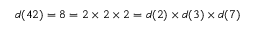Convert formula to latex. <formula><loc_0><loc_0><loc_500><loc_500>d ( 4 2 ) = 8 = 2 \times 2 \times 2 = d ( 2 ) \times d ( 3 ) \times d ( 7 )</formula> 